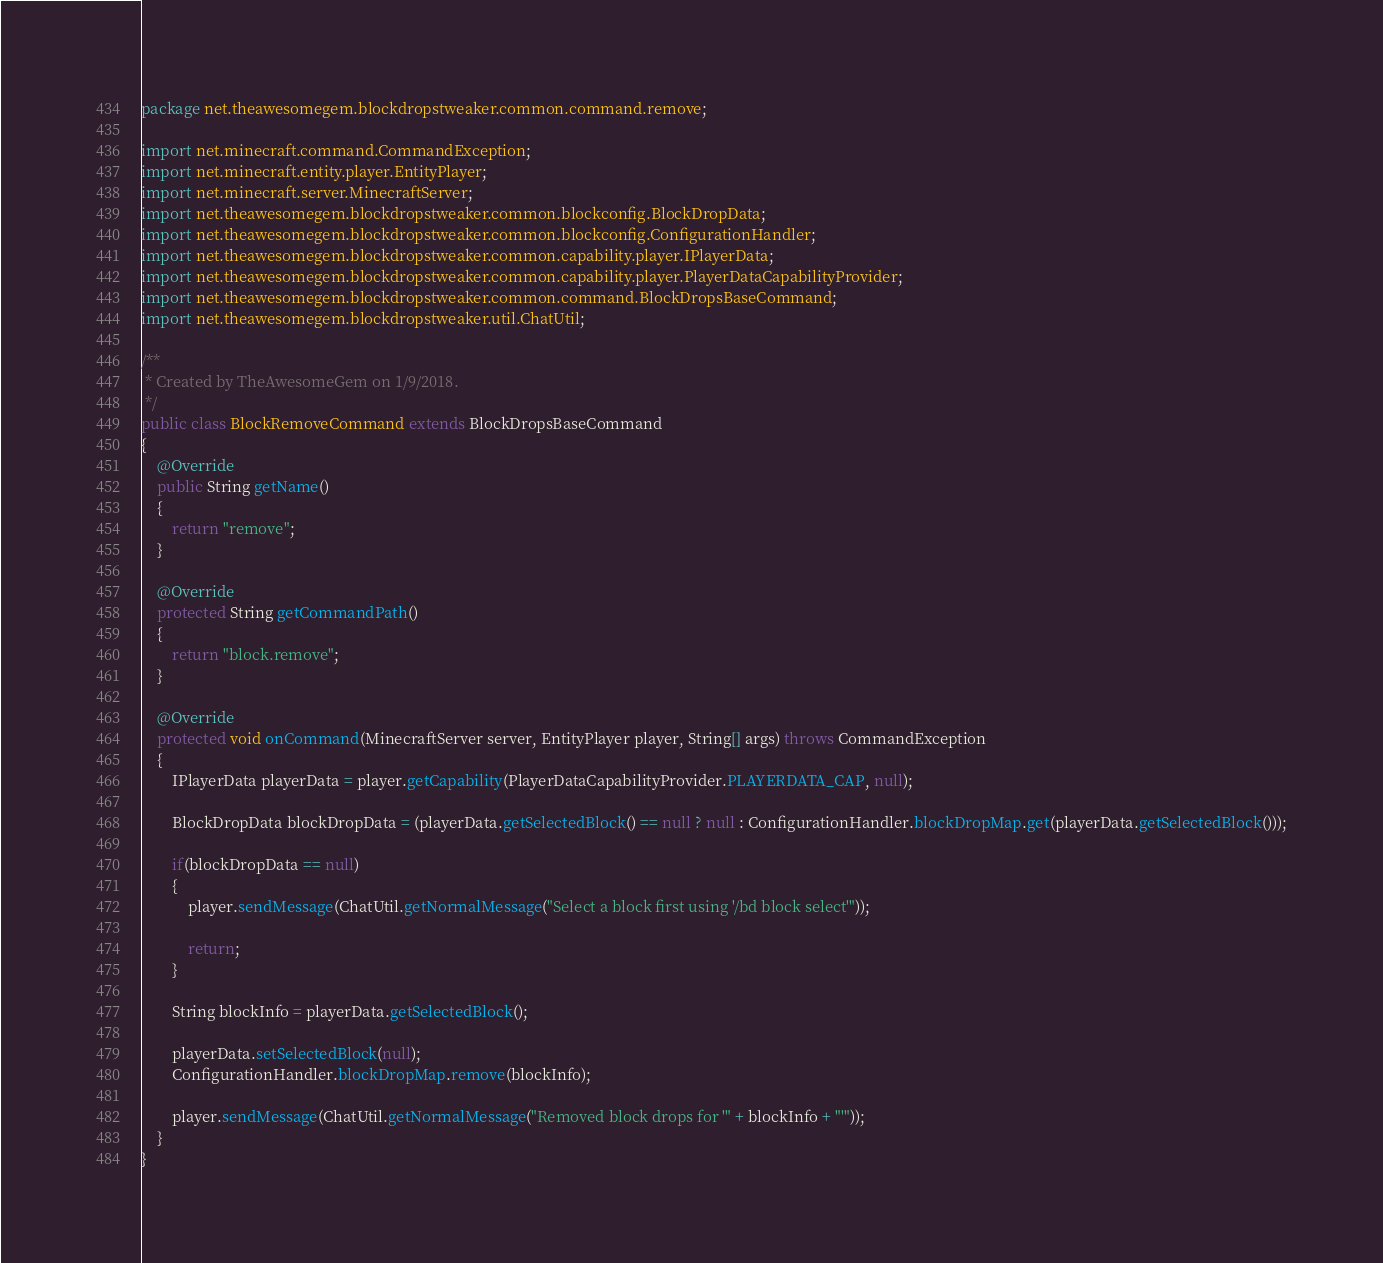Convert code to text. <code><loc_0><loc_0><loc_500><loc_500><_Java_>package net.theawesomegem.blockdropstweaker.common.command.remove;

import net.minecraft.command.CommandException;
import net.minecraft.entity.player.EntityPlayer;
import net.minecraft.server.MinecraftServer;
import net.theawesomegem.blockdropstweaker.common.blockconfig.BlockDropData;
import net.theawesomegem.blockdropstweaker.common.blockconfig.ConfigurationHandler;
import net.theawesomegem.blockdropstweaker.common.capability.player.IPlayerData;
import net.theawesomegem.blockdropstweaker.common.capability.player.PlayerDataCapabilityProvider;
import net.theawesomegem.blockdropstweaker.common.command.BlockDropsBaseCommand;
import net.theawesomegem.blockdropstweaker.util.ChatUtil;

/**
 * Created by TheAwesomeGem on 1/9/2018.
 */
public class BlockRemoveCommand extends BlockDropsBaseCommand
{
    @Override
    public String getName()
    {
        return "remove";
    }

    @Override
    protected String getCommandPath()
    {
        return "block.remove";
    }

    @Override
    protected void onCommand(MinecraftServer server, EntityPlayer player, String[] args) throws CommandException
    {
        IPlayerData playerData = player.getCapability(PlayerDataCapabilityProvider.PLAYERDATA_CAP, null);

        BlockDropData blockDropData = (playerData.getSelectedBlock() == null ? null : ConfigurationHandler.blockDropMap.get(playerData.getSelectedBlock()));

        if(blockDropData == null)
        {
            player.sendMessage(ChatUtil.getNormalMessage("Select a block first using '/bd block select'"));

            return;
        }

        String blockInfo = playerData.getSelectedBlock();

        playerData.setSelectedBlock(null);
        ConfigurationHandler.blockDropMap.remove(blockInfo);

        player.sendMessage(ChatUtil.getNormalMessage("Removed block drops for '" + blockInfo + "'"));
    }
}
</code> 